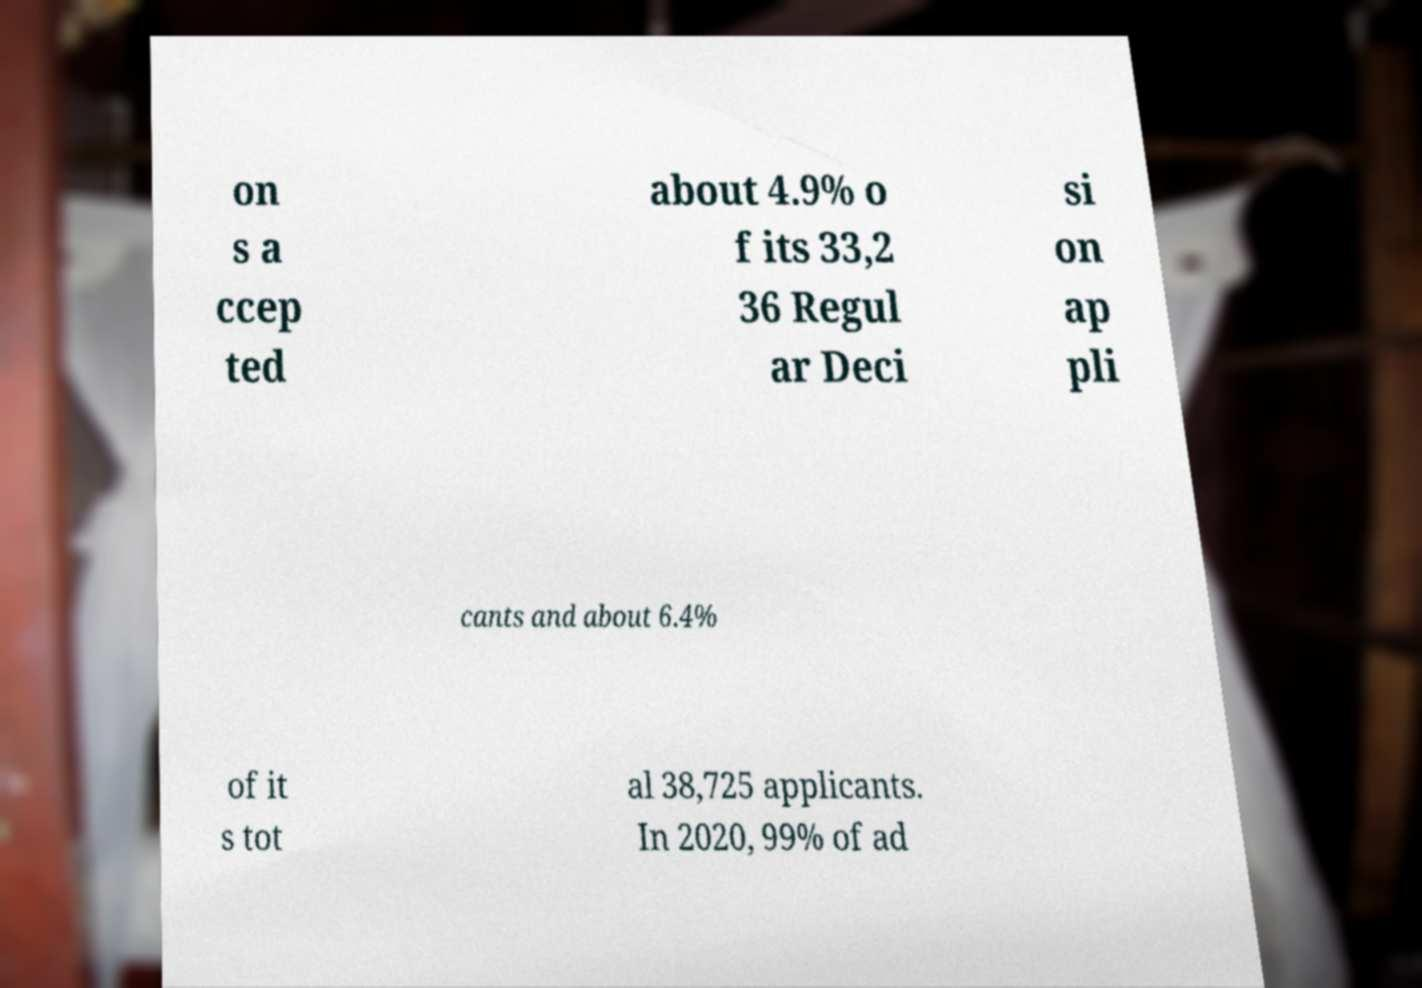Can you accurately transcribe the text from the provided image for me? on s a ccep ted about 4.9% o f its 33,2 36 Regul ar Deci si on ap pli cants and about 6.4% of it s tot al 38,725 applicants. In 2020, 99% of ad 